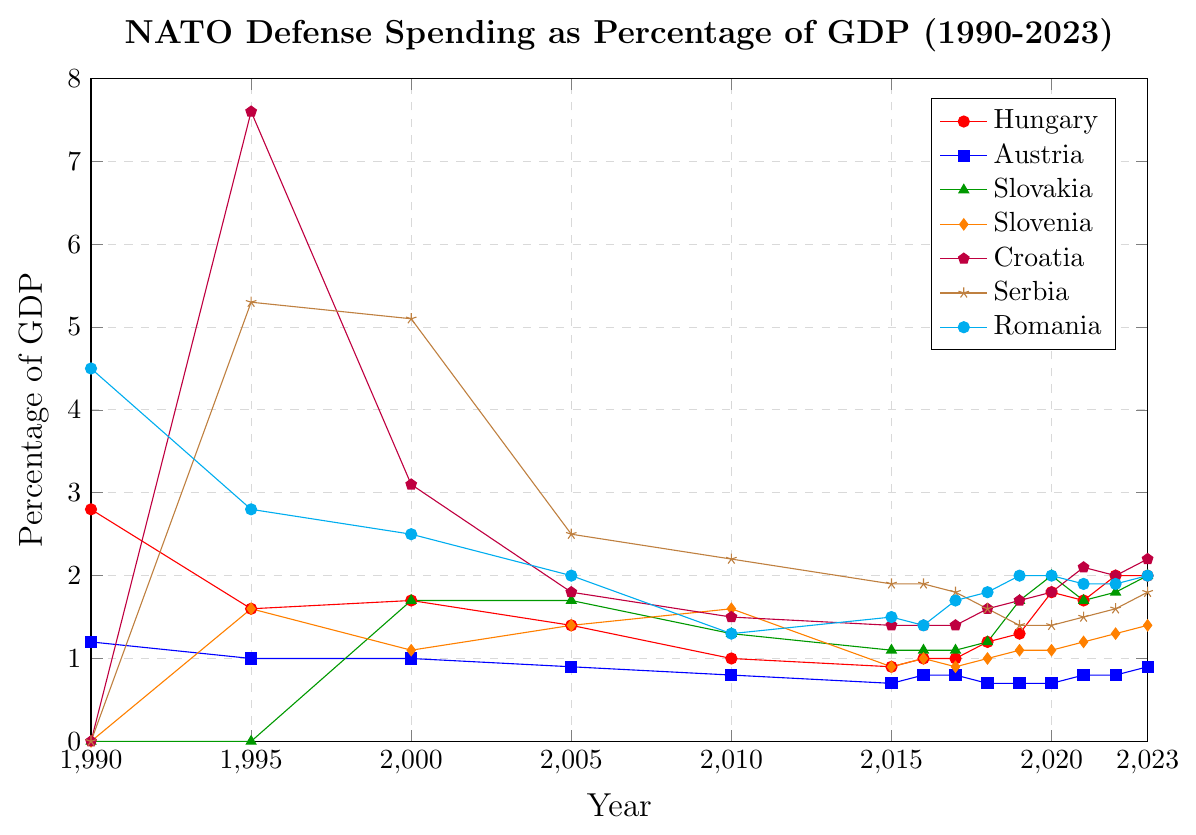What is the overall trend in Hungary's NATO defense spending as a percentage of GDP from 1990 to 2023? Hungary's defense spending as a percentage of GDP has shown a general decrease from 1990 (2.8%) until around 2010 (1.0%). After 2015, the percentage starts to increase again, peaking at 2.0% in 2022 and 2023.
Answer: Decreased then increased Which country had the highest defense spending as a percentage of GDP in 1995? Croatia had the highest defense spending in 1995 at 7.6%.
Answer: Croatia In what year did Romania's defense spending as a percentage of GDP drop the most compared to the previous year? To find the year with the largest drop, we subtract each year's percentage from its preceding year. The largest drop is from 1990 (4.5%) to 1995 (2.8%), where it dropped by 1.7%.
Answer: 1995 Comparing Hungary and Croatia, which country had a lower defense spending percentage in 2015, and by how much? Hungary's percentage in 2015 was 0.9%, while Croatia's was 1.4%. The difference is 1.4% - 0.9% = 0.5%.
Answer: Hungary by 0.5% What is the average NATO defense spending as a percentage of GDP for Austria from 1990 to 2023? Sum the percentages for Austria over the available years and divide by the number of data points:
(1.2 + 1.0 + 1.0 + 0.9 + 0.8 + 0.7 + 0.8 + 0.8 + 0.7 + 0.7 + 0.8 + 0.8 + 0.9)/13 = 10.3/13 = 0.8
Answer: 0.8 Which country consistently had lower defense spending as a percentage of GDP compared to Hungary from 1995 to 2023? Austria consistently had lower defense spending than Hungary in each year provided from 1995 to 2023.
Answer: Austria What was the total change in Serbia's defense spending as a percentage of GDP from 1995 to 2023? Serbia's defense spending in 1995 was 5.3% and in 2023 it was 1.8%. The change is 5.3% - 1.8% = 3.5%.
Answer: 3.5% How many years did Hungary have a defense spending of 1.0% or lower between 1990 and 2023? Count the years where Hungary's defense spending was 1.0% or lower: 2010, 2015, 2016, 2017. So, it is 4 years.
Answer: 4 Which country had the highest defense spending as a percentage of GDP in the year 2000, and what was the percentage? Croatia had the highest defense spending in 2000 at 3.1%.
Answer: Croatia, 3.1% 